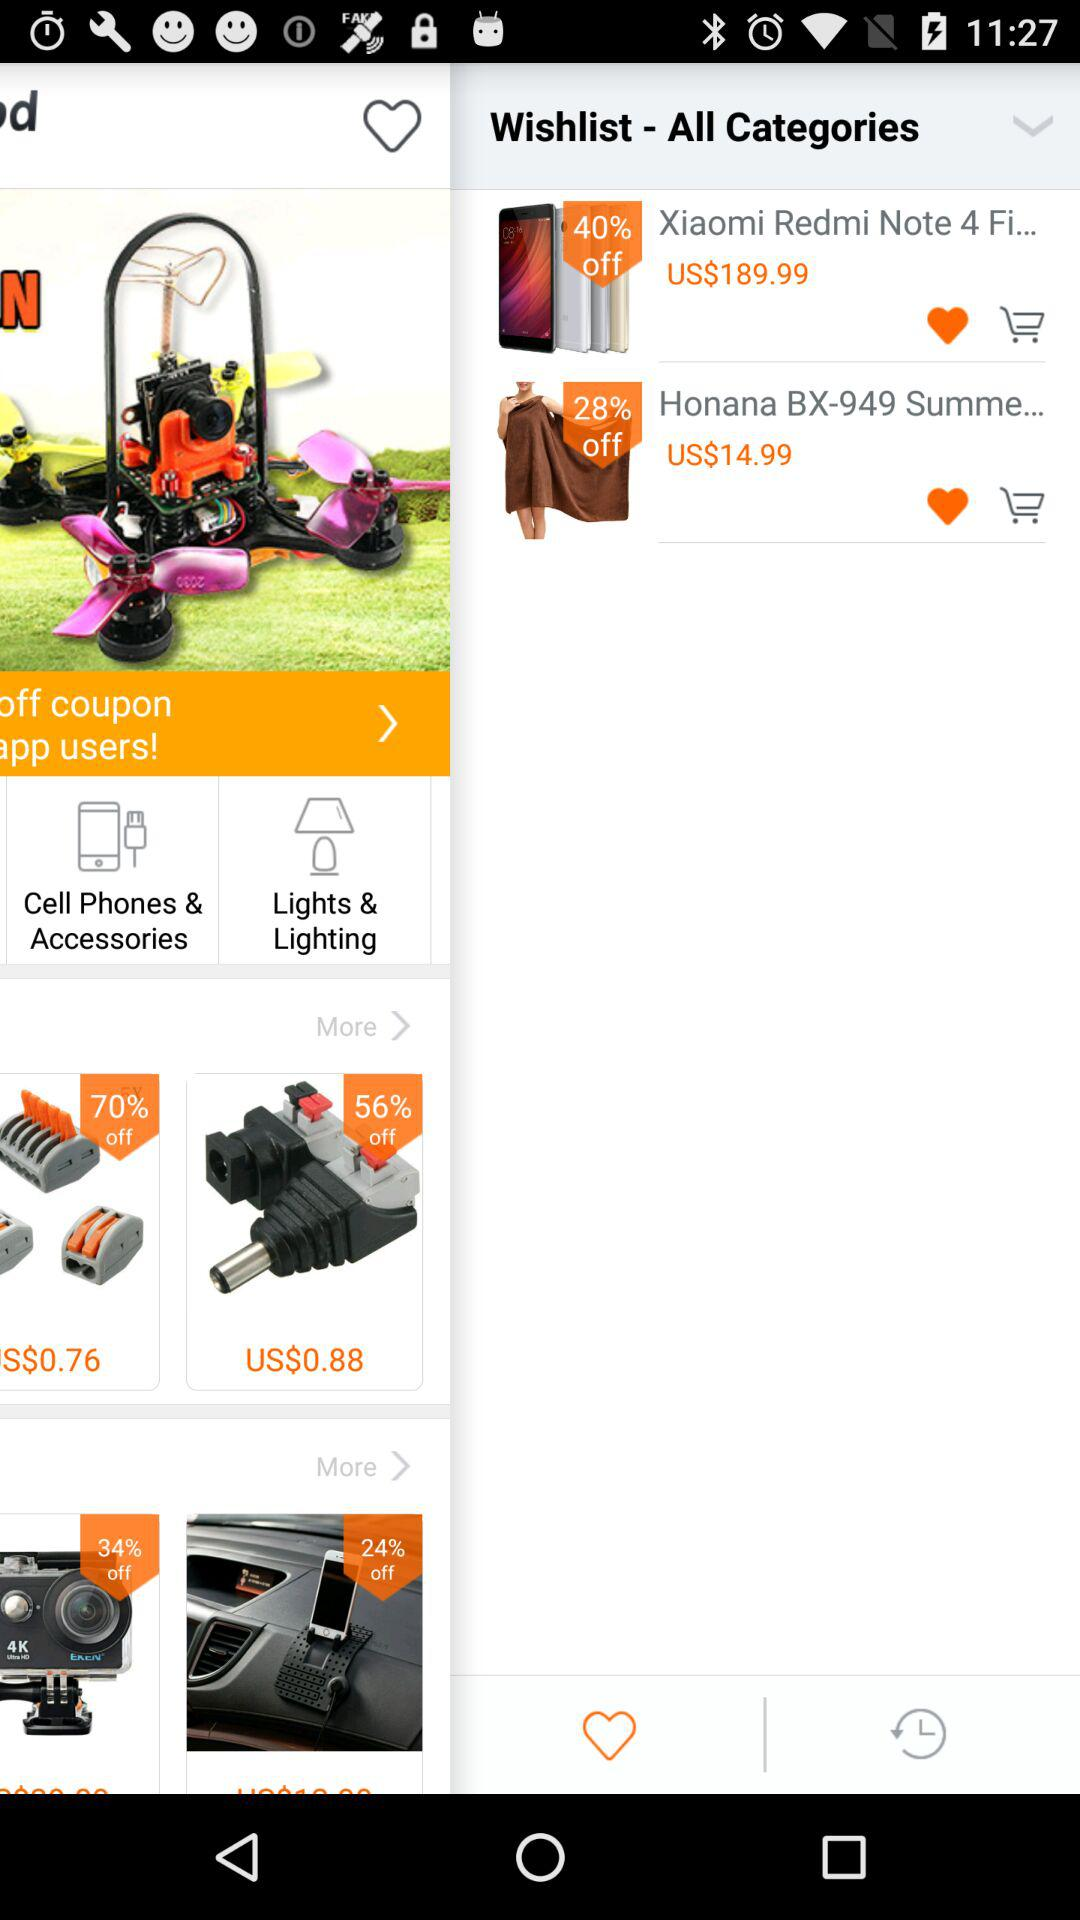What is the percentage off on the "Xiaomi Redmi Note 4"? The percentage off on the "Xiaomi Redmi Note 4" is 40. 